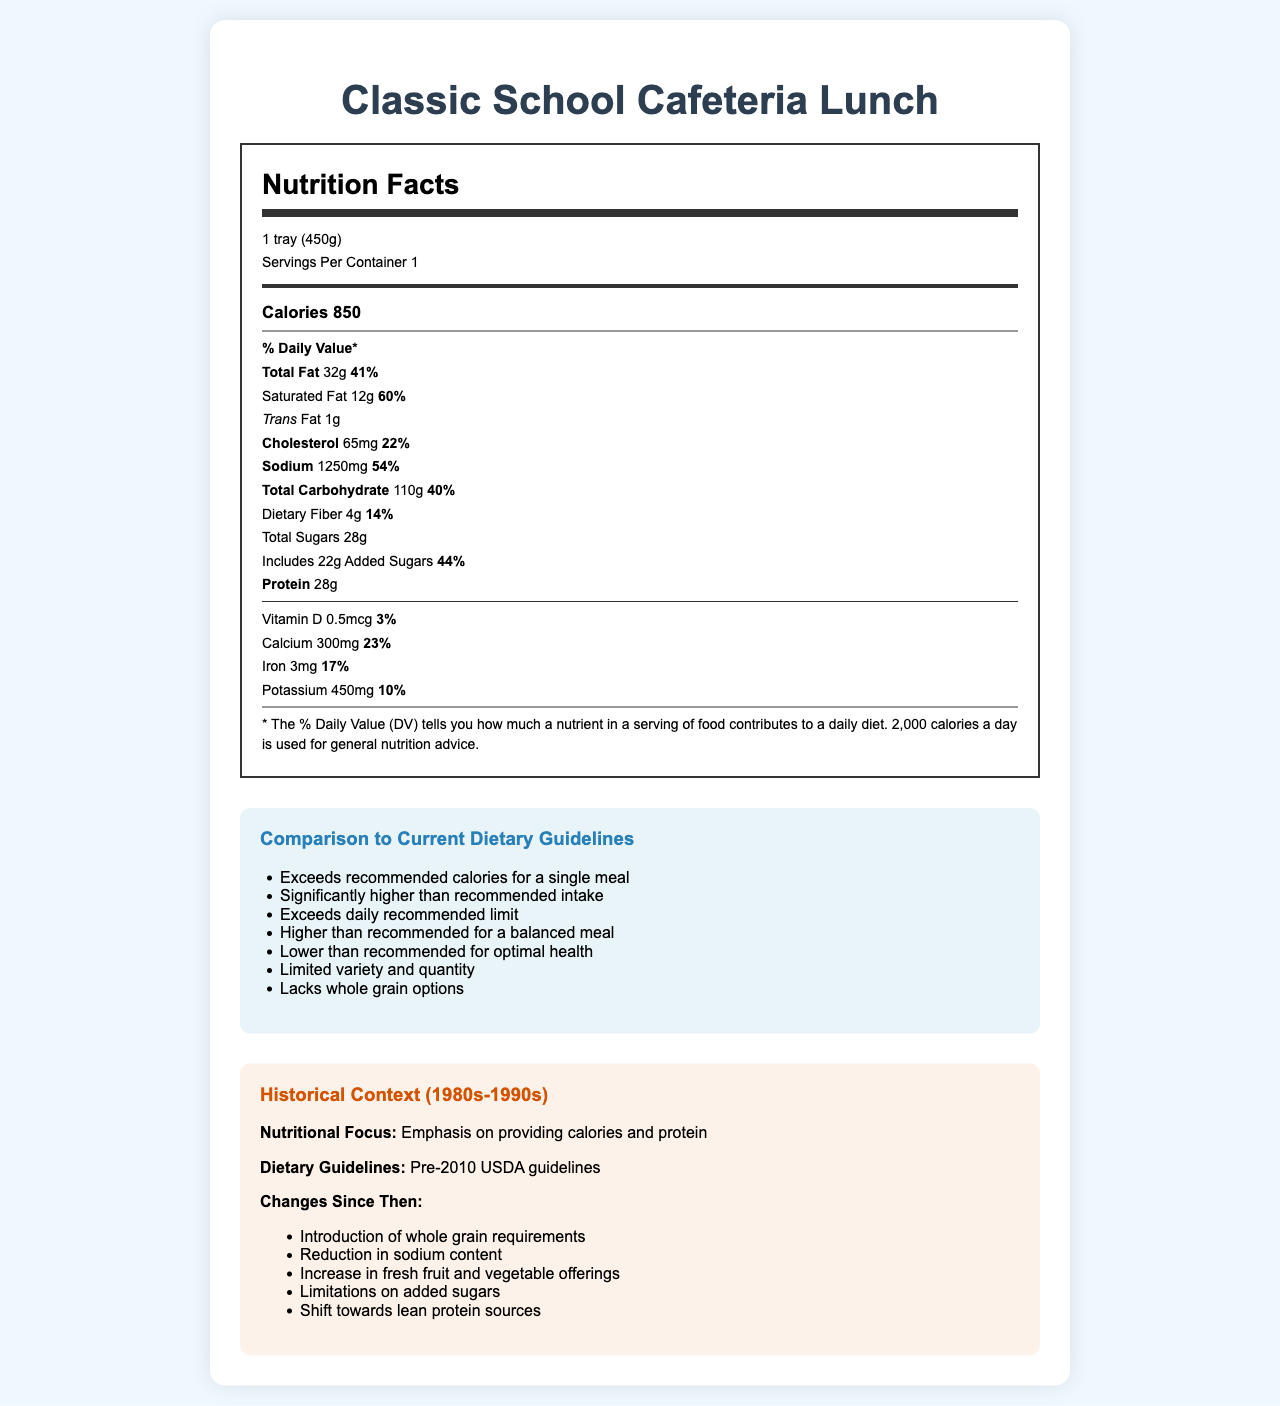what is the serving size? The serving size is displayed in the first section of the Nutrition Facts label as "1 tray (450g)".
Answer: 1 tray (450g) how many calories are in one serving? The calories are listed in the Nutrition Facts label with a bold indicator showing "Calories 850".
Answer: 850 calories what is the % Daily Value for total fat? The % Daily Value for total fat is shown as "41%" next to the total fat amount of "32g".
Answer: 41% how much sodium does the meal contain? The sodium content is listed in the Nutrition Facts label as "Sodium 1250mg" with a % Daily Value of "54%".
Answer: 1250 mg which meal components are included in the Classic School Cafeteria Lunch? The meal components are listed under the "meal_components" section in the document.
Answer: Salisbury steak, Mashed potatoes, Canned green beans, White bread roll, Chocolate milk which nutrient exceeds its daily recommended limit? A. Calcium B. Protein C. Sodium D. Potassium The comparison to current dietary guidelines indicates that sodium exceeds the daily recommended limit.
Answer: C. Sodium how much of the total carbohydrate content is sugars? A. 4g B. 28g C. 110g D. 22g The nutrition label lists "Total Sugars" as 28g under the total carbohydrate section.
Answer: B. 28g Is there any whole grain option included in this meal? The document states that the meal "Lacks whole grain options" in the comparison to current dietary guidelines section.
Answer: No summarize the main points of the document. The document lists detailed nutritional information for a traditional school cafeteria meal, highlights how it compares poorly to current dietary guidelines, and provides historical context and recent changes in school nutrition standards.
Answer: The document provides the nutrition facts for a Classic School Cafeteria Lunch, which includes high calorie counts, high levels of saturated fats, sodium, and added sugars. Comparison to current dietary guidelines shows that the meal exceeds recommendations in several areas. Historical context shows this meal was typical in the 1980s-1990s, with changes made since then to improve school nutrition standards. how many grams of dietary fiber are in the meal? The dietary fiber content is listed as "4g" in the Nutrition Facts label.
Answer: 4g how does the calcium percent daily value compare to the iron percent daily value? The % Daily Values for calcium (23%) and iron (17%) are listed in the Nutrition Facts label.
Answer: Calcium 23%, Iron 17% What are some changes in school nutrition standards since the 1980s-1990s? The changes in school nutrition standards are detailed under the "changes since then" section in the historical context.
Answer: Introduction of whole grain requirements, Reduction in sodium content, Increase in fresh fruit and vegetable offerings, Limitations on added sugars, Shift towards lean protein sources what dietary guidelines were in effect when the traditional school cafeteria meal was common? The historical context section mentions that the dietary guidelines were based on "Pre-2010 USDA guidelines."
Answer: Pre-2010 USDA guidelines how many added sugars are included in the meal? The meal includes 22g of added sugars as listed under Total Sugars in the Nutrition Facts label.
Answer: 22g what is the historical era of the "Classic School Cafeteria Lunch"? The historical era is stated as "1980s-1990s" in the historical context section of the document.
Answer: 1980s-1990s to what nutritional focus does the document attribute the traditional school cafeteria meal? The nutritional focus for the traditional meal is described in the historical context as "Emphasis on providing calories and protein."
Answer: Emphasis on providing calories and protein does the meal meet current recommendations for dietary fiber? The comparison to guidelines notes that the dietary fiber is lower than recommended for optimal health.
Answer: No what flavor of milk is included in the meal components? One of the meal components listed is "Chocolate milk."
Answer: Chocolate milk What is the % Daily Value for vitamin D in this meal? The % Daily Value for vitamin D is listed as "3%" in the Nutrition Facts label.
Answer: 3% what are the learning objectives for nutrition education mentioned in the document? The learning objectives for nutrition education are listed in the "educational_value" section of the document.
Answer: Understand the evolution of school nutrition standards, Compare historical meals to current dietary recommendations, Analyze the nutritional content of a typical meal, Identify areas for improvement in school lunch programs How much trans fat is in the meal? The trans fat content is listed as "1g" in the Nutrition Facts label.
Answer: 1g What is the source of protein included in the meal components? The Salisbury steak is identified as the likely major source of protein among the meal components listed.
Answer: Salisbury steak what type of bread is included in the meal components? The meal components list includes "White bread roll."
Answer: White bread roll Is the exact breakdown of macronutrient distribution (carbs, fats, proteins, etc.) provided? The document provides the amounts but not the exact macronutrient distribution percentages relative to each other.
Answer: No 